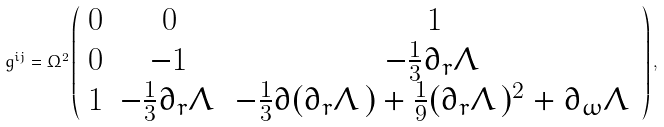<formula> <loc_0><loc_0><loc_500><loc_500>g ^ { i j } = \Omega ^ { 2 } \left ( \begin{array} { c c c } 0 & 0 & 1 \\ 0 & - 1 & - \frac { 1 } { 3 } \partial _ { r } \Lambda \, \\ 1 & - \frac { 1 } { 3 } \partial _ { r } \Lambda \, & - \frac { 1 } { 3 } \partial ( \partial _ { r } \Lambda \, ) + \frac { 1 } { 9 } ( \partial _ { r } \Lambda \, ) ^ { 2 } + \partial _ { \omega } \Lambda \, \end{array} \right ) ,</formula> 